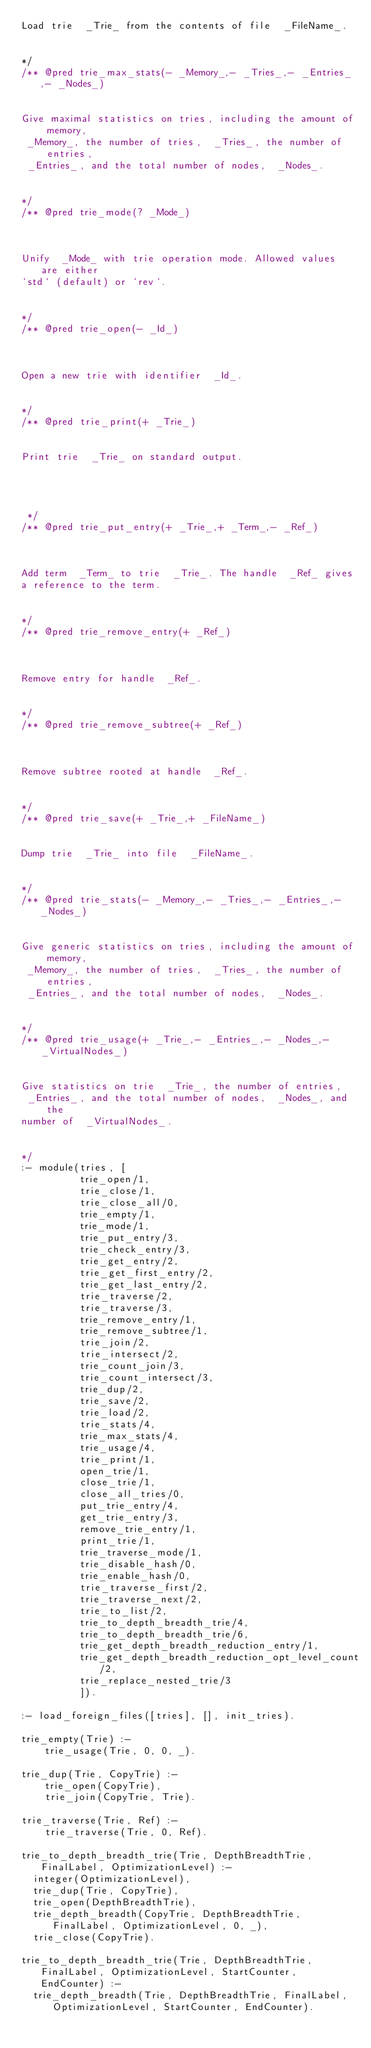Convert code to text. <code><loc_0><loc_0><loc_500><loc_500><_Prolog_>Load trie  _Trie_ from the contents of file  _FileName_.

 
*/
/** @pred trie_max_stats(- _Memory_,- _Tries_,- _Entries_,- _Nodes_) 


Give maximal statistics on tries, including the amount of memory,
 _Memory_, the number of tries,  _Tries_, the number of entries,
 _Entries_, and the total number of nodes,  _Nodes_.

 
*/
/** @pred trie_mode(? _Mode_) 



Unify  _Mode_ with trie operation mode. Allowed values are either
`std` (default) or `rev`.

 
*/
/** @pred trie_open(- _Id_) 



Open a new trie with identifier  _Id_.

 
*/
/** @pred trie_print(+ _Trie_) 


Print trie  _Trie_ on standard output.




 */
/** @pred trie_put_entry(+ _Trie_,+ _Term_,- _Ref_) 



Add term  _Term_ to trie  _Trie_. The handle  _Ref_ gives
a reference to the term.

 
*/
/** @pred trie_remove_entry(+ _Ref_) 



Remove entry for handle  _Ref_.

 
*/
/** @pred trie_remove_subtree(+ _Ref_) 



Remove subtree rooted at handle  _Ref_.

 
*/
/** @pred trie_save(+ _Trie_,+ _FileName_) 


Dump trie  _Trie_ into file  _FileName_.

 
*/
/** @pred trie_stats(- _Memory_,- _Tries_,- _Entries_,- _Nodes_) 


Give generic statistics on tries, including the amount of memory,
 _Memory_, the number of tries,  _Tries_, the number of entries,
 _Entries_, and the total number of nodes,  _Nodes_.

 
*/
/** @pred trie_usage(+ _Trie_,- _Entries_,- _Nodes_,- _VirtualNodes_) 


Give statistics on trie  _Trie_, the number of entries,
 _Entries_, and the total number of nodes,  _Nodes_, and the
number of  _VirtualNodes_.

 
*/
:- module(tries, [
		  trie_open/1,
		  trie_close/1,
		  trie_close_all/0,
		  trie_empty/1,
		  trie_mode/1,
		  trie_put_entry/3,
		  trie_check_entry/3,
		  trie_get_entry/2,
		  trie_get_first_entry/2,
		  trie_get_last_entry/2,
		  trie_traverse/2,
		  trie_traverse/3,
		  trie_remove_entry/1,
		  trie_remove_subtree/1,
		  trie_join/2,
		  trie_intersect/2,
		  trie_count_join/3,
		  trie_count_intersect/3,
		  trie_dup/2,
		  trie_save/2,
		  trie_load/2,
		  trie_stats/4,
		  trie_max_stats/4,
		  trie_usage/4,
		  trie_print/1,
		  open_trie/1,
		  close_trie/1,
		  close_all_tries/0,
		  put_trie_entry/4,
		  get_trie_entry/3,
		  remove_trie_entry/1,
		  print_trie/1,
          trie_traverse_mode/1,
          trie_disable_hash/0,
          trie_enable_hash/0,
          trie_traverse_first/2,
          trie_traverse_next/2,
          trie_to_list/2,
          trie_to_depth_breadth_trie/4,
          trie_to_depth_breadth_trie/6,
          trie_get_depth_breadth_reduction_entry/1,
          trie_get_depth_breadth_reduction_opt_level_count/2,
          trie_replace_nested_trie/3
          ]).

:- load_foreign_files([tries], [], init_tries).

trie_empty(Trie) :-
	trie_usage(Trie, 0, 0, _).

trie_dup(Trie, CopyTrie) :-
	trie_open(CopyTrie),
	trie_join(CopyTrie, Trie).

trie_traverse(Trie, Ref) :- 
	trie_traverse(Trie, 0, Ref).

trie_to_depth_breadth_trie(Trie, DepthBreadthTrie, FinalLabel, OptimizationLevel) :-
  integer(OptimizationLevel),
  trie_dup(Trie, CopyTrie),
  trie_open(DepthBreadthTrie),
  trie_depth_breadth(CopyTrie, DepthBreadthTrie, FinalLabel, OptimizationLevel, 0, _),
  trie_close(CopyTrie).

trie_to_depth_breadth_trie(Trie, DepthBreadthTrie, FinalLabel, OptimizationLevel, StartCounter, EndCounter) :-
  trie_depth_breadth(Trie, DepthBreadthTrie, FinalLabel, OptimizationLevel, StartCounter, EndCounter).
</code> 